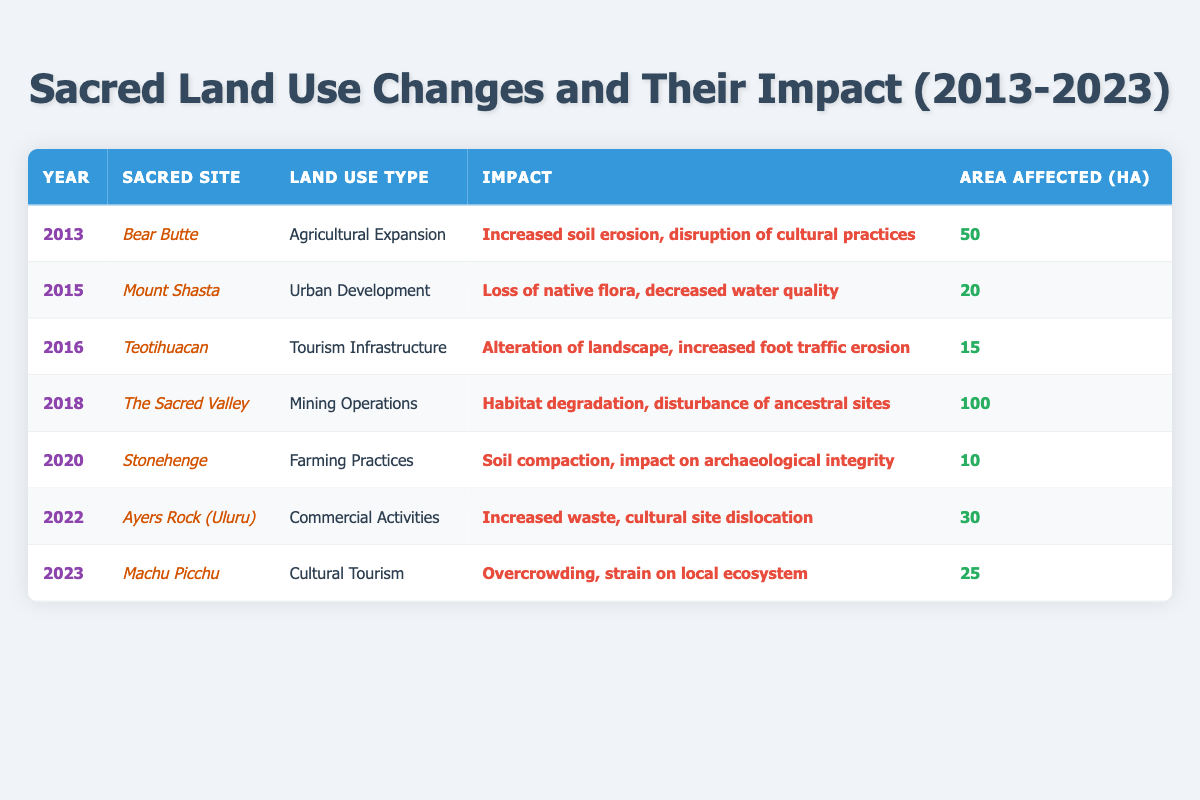What is the area affected by Agricultural Expansion at Bear Butte in 2013? The table indicates that Bear Butte was affected by Agricultural Expansion in 2013. The area affected is explicitly stated under the "Area Affected (ha)" column, which shows the value as 50.
Answer: 50 Which sacred site experienced the largest area affected in the decade? To determine the largest area affected, I can look for the maximum value in the "Area Affected (ha)" column. The Sacred Valley shows 100 hectares affected in 2018, which is greater than any other values listed in the table.
Answer: The Sacred Valley How many years saw impacts due to urban development? By scanning the "Land Use Type" column for occurrences of "Urban Development," I find that there is only one entry (Mount Shasta in 2015). Therefore, the total number of years is 1.
Answer: 1 What is the total area affected due to tourism-related impacts over the years? Tourism-related impacts include "Tourism Infrastructure" at Teotihuacan in 2016 (15 ha) and "Cultural Tourism" at Machu Picchu in 2023 (25 ha). Summing these provides: 15 + 25 = 40.
Answer: 40 Was there any land use change affecting sacred sites that resulted in habitat degradation? Reviewing the "Impact" column for occurrences of "habitat degradation," the only entry is related to mining operations in The Sacred Valley in 2018. Hence, the answer is yes.
Answer: Yes What was the average area affected by land use changes across all sacred sites in the table? I sum the areas listed: 50 + 20 + 15 + 100 + 10 + 30 + 25 = 250. There are 7 entries. So, the average is 250 / 7 equals approximately 35.71.
Answer: Approximately 35.71 In which year did Ayers Rock (Uluru) face commercial activities affecting the sacred site? The table lists Ayers Rock (Uluru) with the land use type "Commercial Activities" in 2022. I can directly locate this in the "Year" column.
Answer: 2022 Which sacred site experienced urban development, and what was its impact? The table shows that Mount Shasta experienced urban development in 2015, and the listed impact was "Loss of native flora, decreased water quality."
Answer: Mount Shasta; Loss of native flora, decreased water quality How many different land use types are listed in the table for the decade? By examining the "Land Use Type" column, the unique values are "Agricultural Expansion," "Urban Development," "Tourism Infrastructure," "Mining Operations," "Farming Practices," "Commercial Activities," and "Cultural Tourism." That results in a total of 7 different types.
Answer: 7 